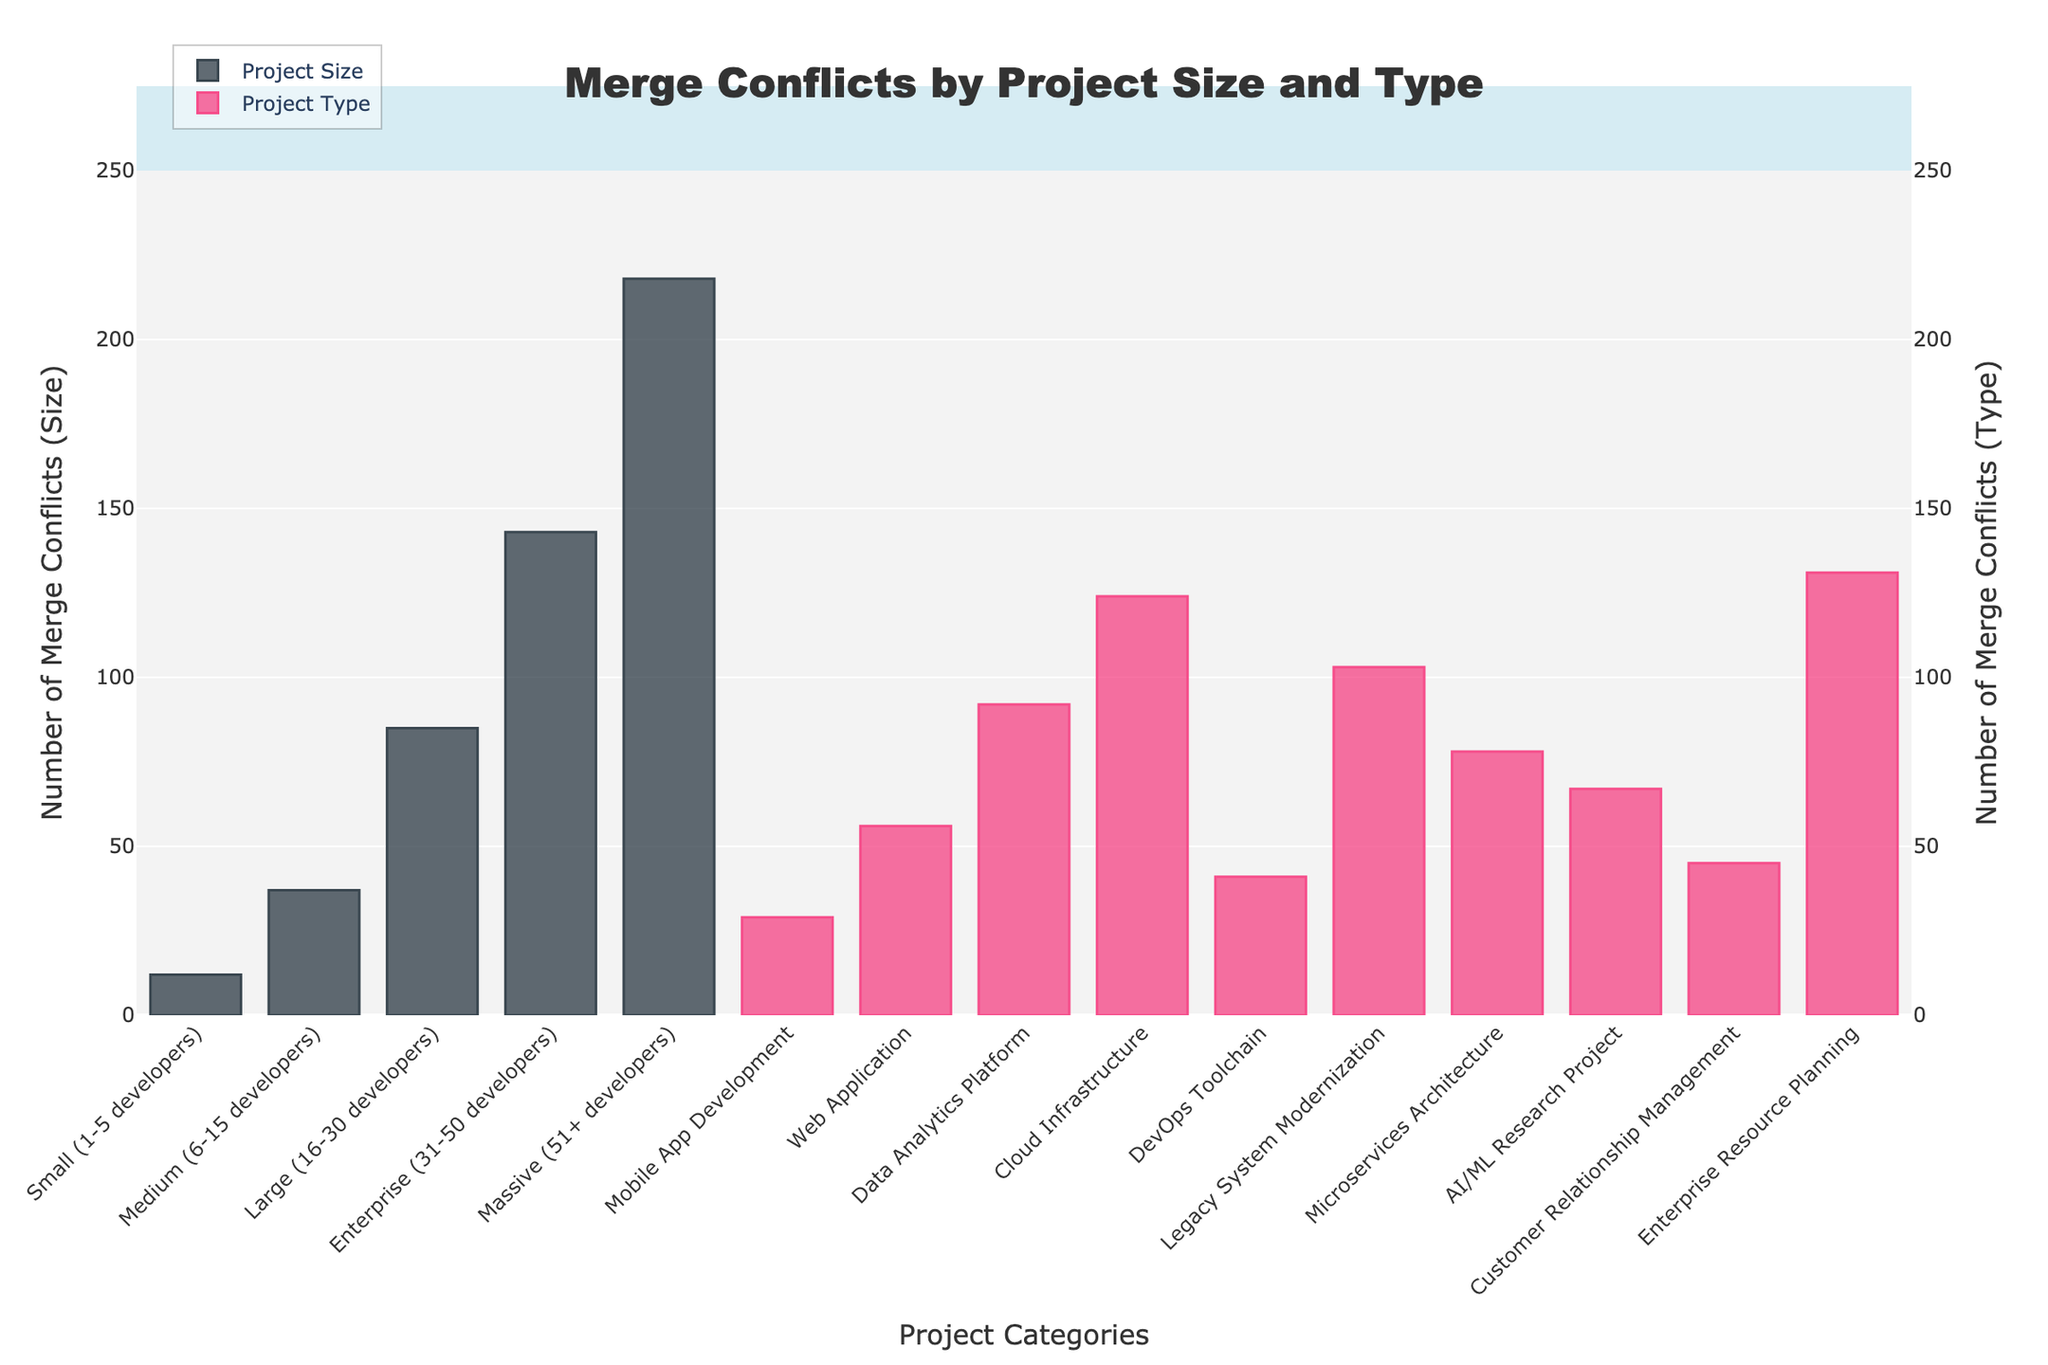What is the project size category with the highest number of merge conflicts? The format shows that "Massive (51+ developers)" is the project size category with the highest bar. The height of the bar indicates 218 merge conflicts.
Answer: Massive (51+ developers) Which project type has more merge conflicts, "Web Application" or "Microservices Architecture"? The height of the bars indicates their values. The "Web Application" bar is higher than that of "Microservices Architecture". The values are 56 for "Web Application" and 78 for "Microservices Architecture".
Answer: Microservices Architecture What is the total number of merge conflicts for all project sizes shown? Add the number of merge conflicts for all project sizes: 12 (Small) + 37 (Medium) + 85 (Large) + 143 (Enterprise) + 218 (Massive) = 495.
Answer: 495 Compare the number of merge conflicts between "Data Analytics Platform" and "DevOps Toolchain". Which project type has fewer merge conflicts and by how much? "Data Analytics Platform" has 92 merge conflicts, while "DevOps Toolchain" has 41. Subtract the smaller from the larger: 92 - 41 = 51. So, "DevOps Toolchain" has 51 fewer merge conflicts.
Answer: DevOps Toolchain, 51 What are the combined merge conflicts for the "AI/ML Research Project" and "Customer Relationship Management" project types? Add the number of merge conflicts: 67 (AI/ML Research Project) + 45 (Customer Relationship Management) = 112.
Answer: 112 Which category (size or type) appears to have more variability in the number of merge conflicts? Visually, "Project Type" bars show more variability in height compared to "Project Size" bars. This observation is more evident as the heights of bars representing different project types (ranging from 29 to 131) vary significantly compared to the project sizes (ranging from 12 to 218).
Answer: Project Type What is the difference in merge conflicts between the largest and smallest project size categories? The largest project size category, "Massive (51+ developers)", has 218 merge conflicts. The smallest, "Small (1-5 developers)", has 12. The difference is 218 - 12 = 206.
Answer: 206 By looking at the figure, what might you infer about the correlation between project size and the number of merge conflicts? Generally, as the project size increases (moving from "Small" to "Massive"), the number of merge conflicts also increases. This implies a positive correlation between project size and the number of merge conflicts.
Answer: Positive correlation How many total merge conflicts are there for all project types shown? Add the number of merge conflicts for all project types: 29 (Mobile App Development) + 56 (Web Application) + 92 (Data Analytics Platform) + 124 (Cloud Infrastructure) + 41 (DevOps Toolchain) + 103 (Legacy System Modernization) + 78 (Microservices Architecture) + 67 (AI/ML Research Project) + 45 (Customer Relationship Management) + 131 (Enterprise Resource Planning) = 766.
Answer: 766 What is the average number of merge conflicts for project sizes "Medium", "Large", and "Enterprise"? Add the merge conflicts for each category: 37 (Medium) + 85 (Large) + 143 (Enterprise) = 265. Then, divide by the number of categories: 265 / 3 = approx. 88.33.
Answer: 88.33 